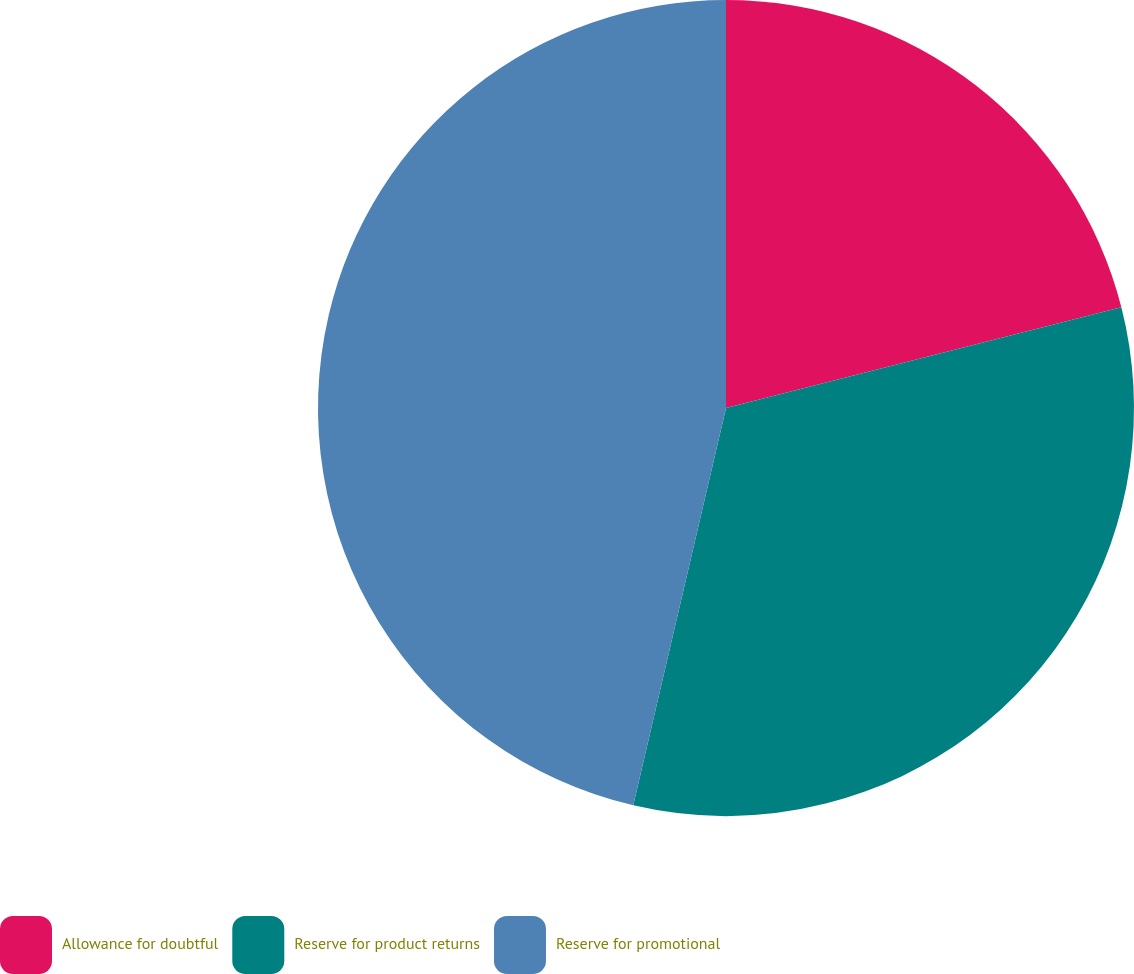Convert chart to OTSL. <chart><loc_0><loc_0><loc_500><loc_500><pie_chart><fcel>Allowance for doubtful<fcel>Reserve for product returns<fcel>Reserve for promotional<nl><fcel>21.03%<fcel>32.62%<fcel>46.35%<nl></chart> 